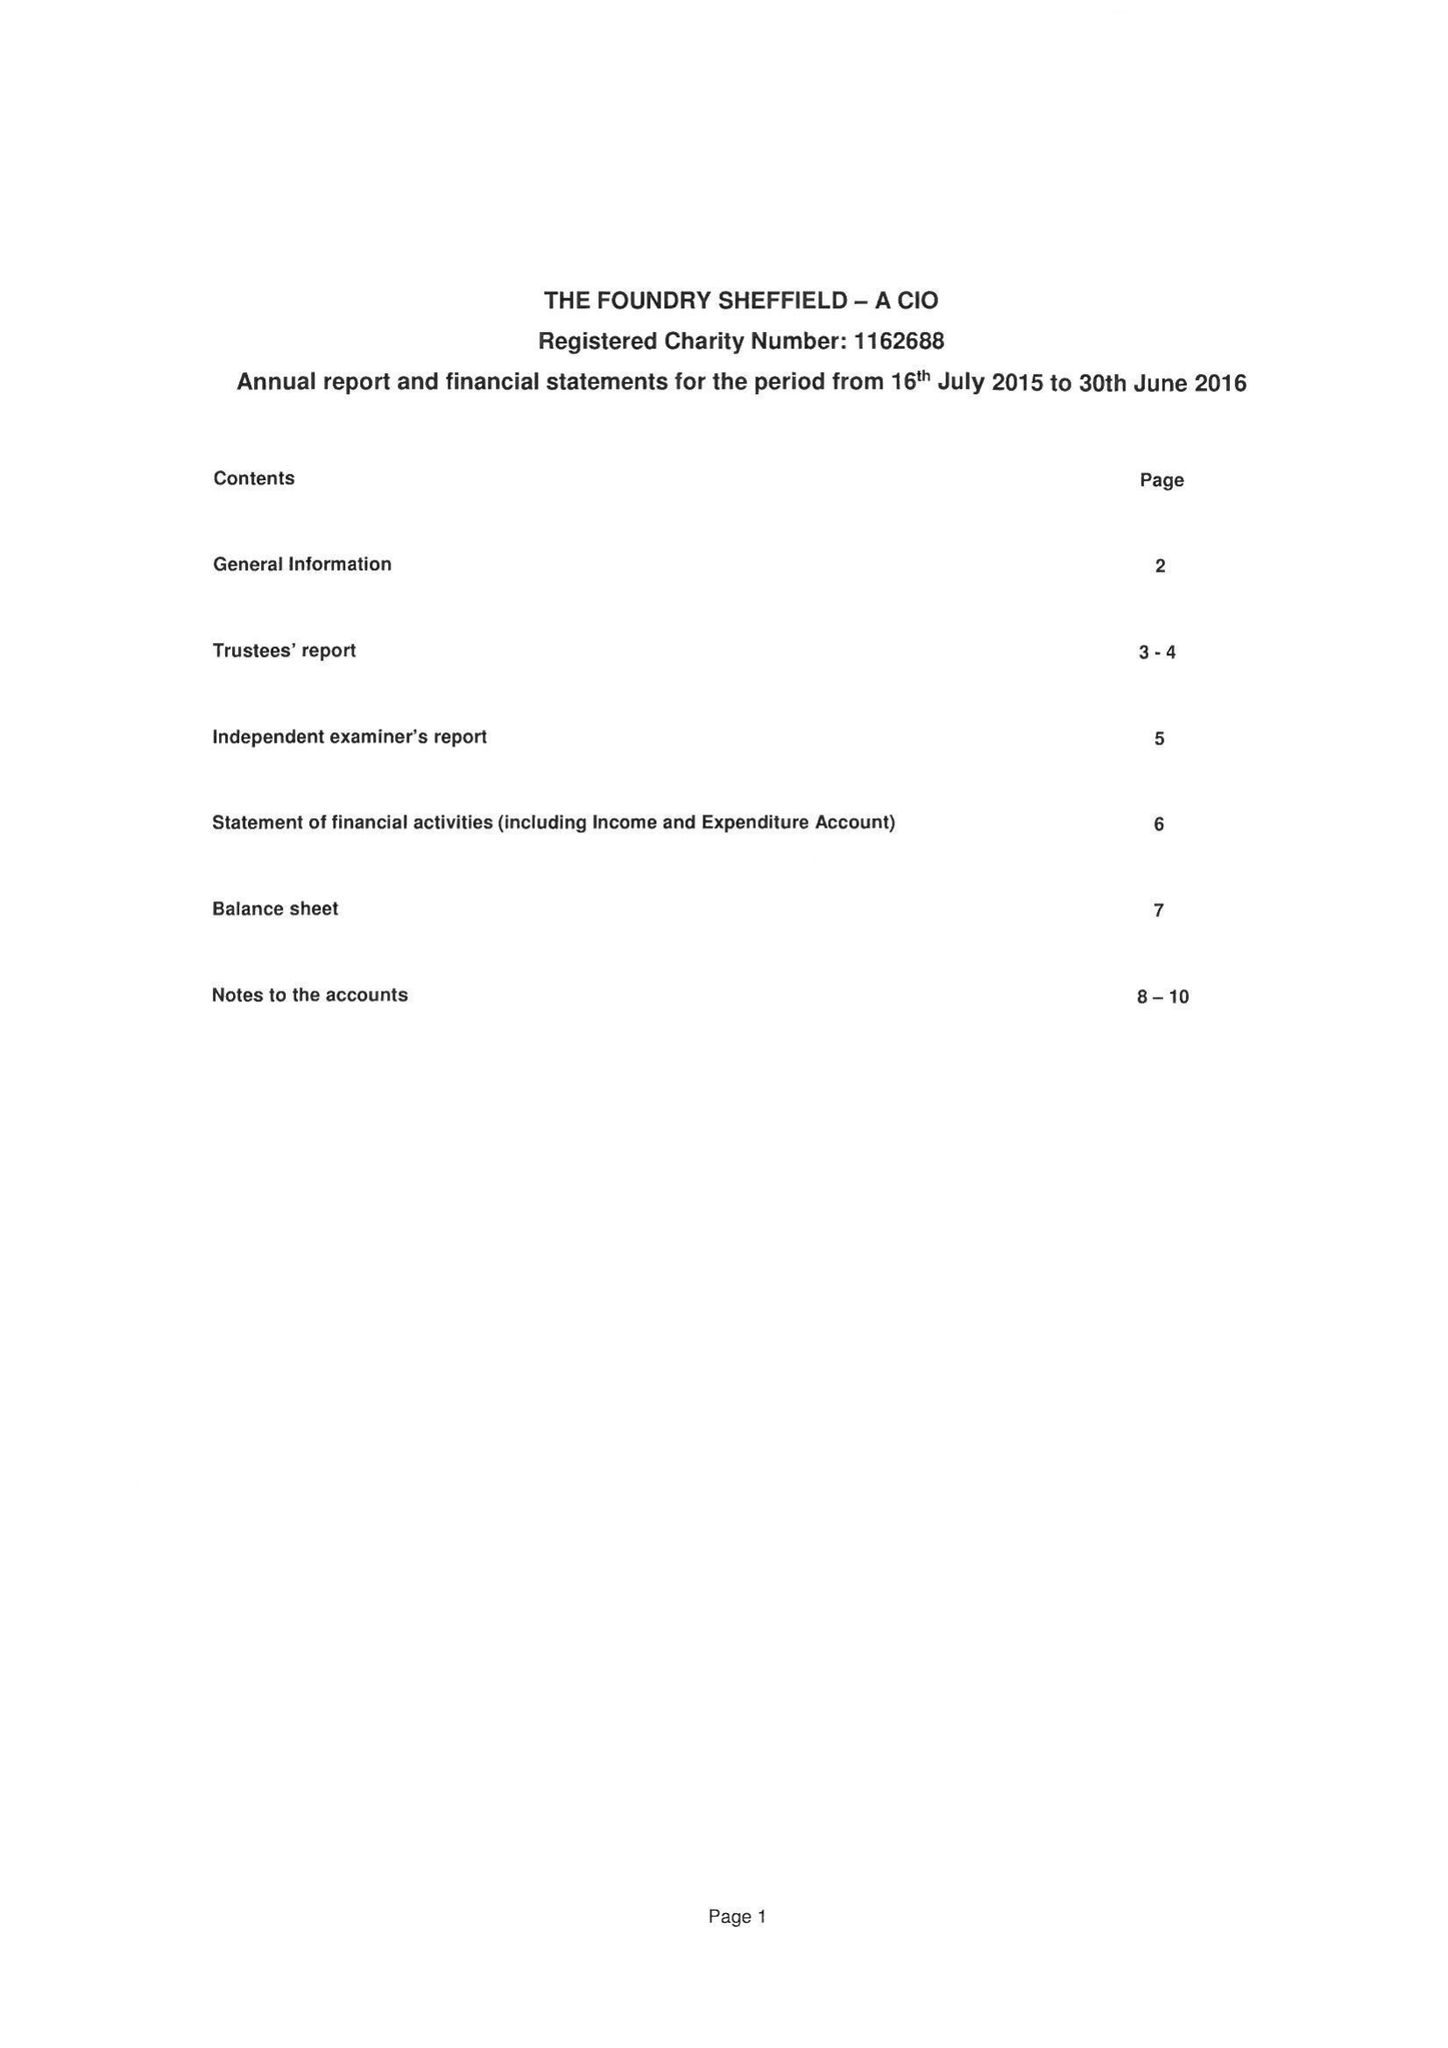What is the value for the address__post_town?
Answer the question using a single word or phrase. SHEFFIELD 